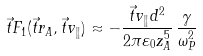<formula> <loc_0><loc_0><loc_500><loc_500>\vec { t } { F } _ { 1 } ( \vec { t } { r } _ { A } , \vec { t } { v } _ { \| } ) \approx - \frac { \vec { t } { v } _ { \| } d ^ { 2 } } { 2 \pi \varepsilon _ { 0 } z _ { A } ^ { 5 } } \, \frac { \gamma } { \omega _ { P } ^ { 2 } }</formula> 